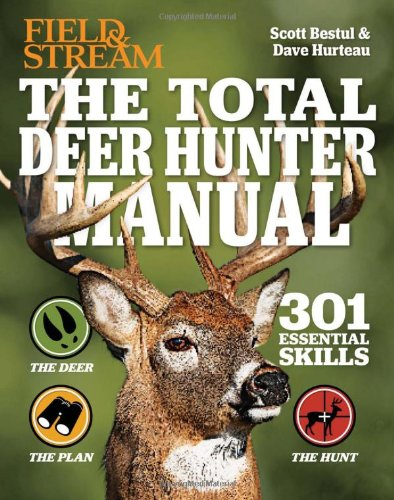Is this a reference book? Yes, 'The Total Deer Hunter Manual' serves as a detailed reference, delivering essential hunting skills comprehensively structured for practical use. 